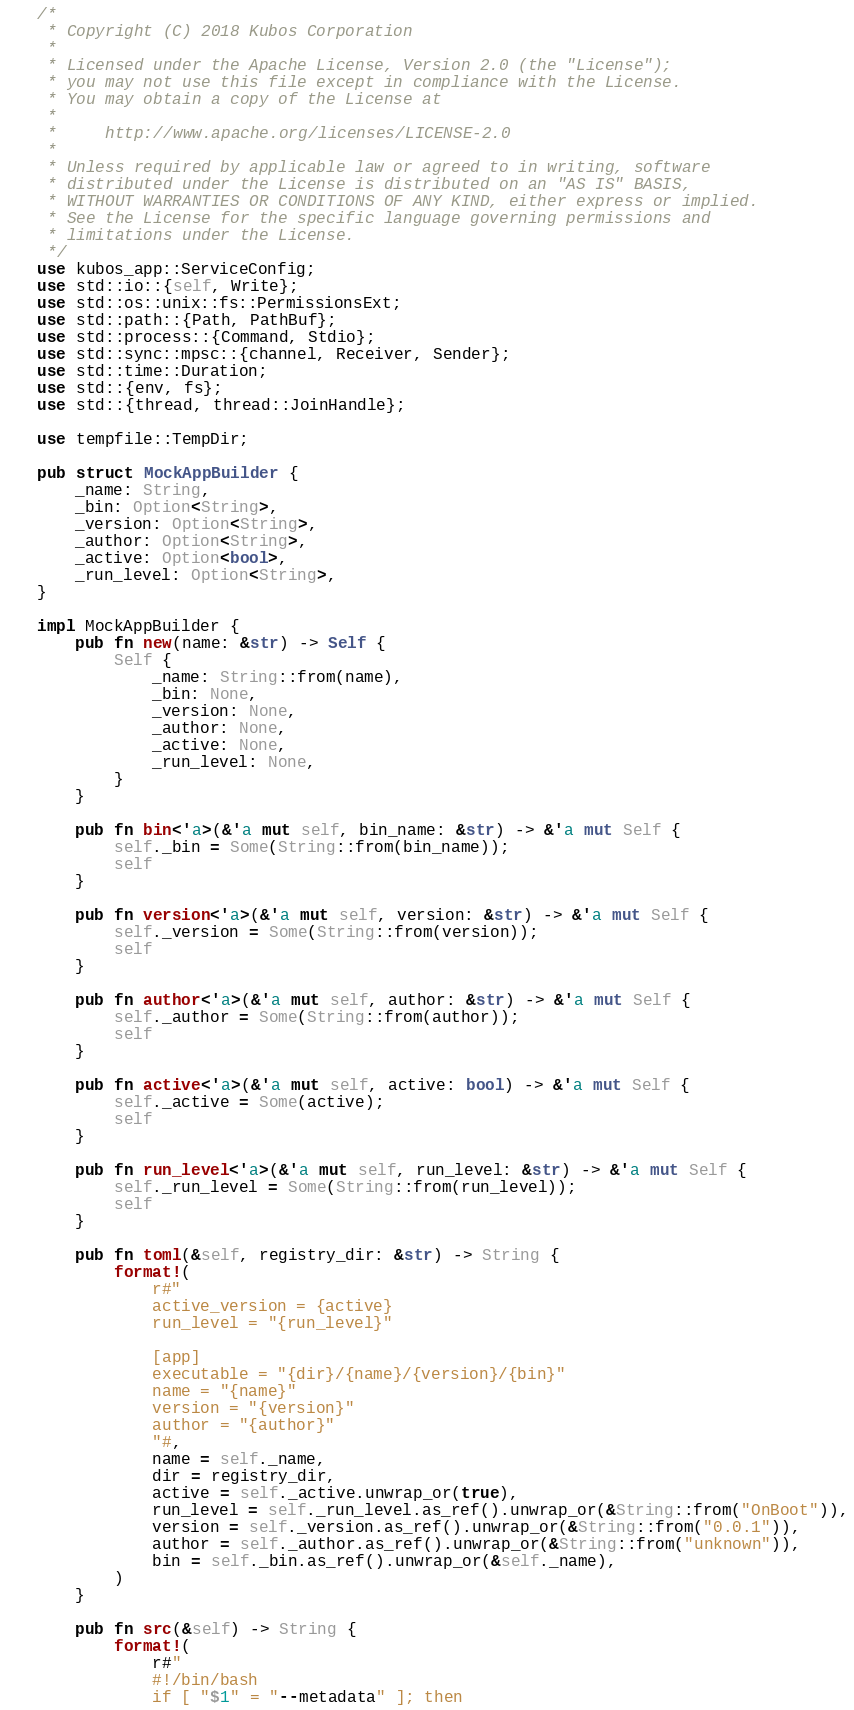<code> <loc_0><loc_0><loc_500><loc_500><_Rust_>/*
 * Copyright (C) 2018 Kubos Corporation
 *
 * Licensed under the Apache License, Version 2.0 (the "License");
 * you may not use this file except in compliance with the License.
 * You may obtain a copy of the License at
 *
 *     http://www.apache.org/licenses/LICENSE-2.0
 *
 * Unless required by applicable law or agreed to in writing, software
 * distributed under the License is distributed on an "AS IS" BASIS,
 * WITHOUT WARRANTIES OR CONDITIONS OF ANY KIND, either express or implied.
 * See the License for the specific language governing permissions and
 * limitations under the License.
 */
use kubos_app::ServiceConfig;
use std::io::{self, Write};
use std::os::unix::fs::PermissionsExt;
use std::path::{Path, PathBuf};
use std::process::{Command, Stdio};
use std::sync::mpsc::{channel, Receiver, Sender};
use std::time::Duration;
use std::{env, fs};
use std::{thread, thread::JoinHandle};

use tempfile::TempDir;

pub struct MockAppBuilder {
    _name: String,
    _bin: Option<String>,
    _version: Option<String>,
    _author: Option<String>,
    _active: Option<bool>,
    _run_level: Option<String>,
}

impl MockAppBuilder {
    pub fn new(name: &str) -> Self {
        Self {
            _name: String::from(name),
            _bin: None,
            _version: None,
            _author: None,
            _active: None,
            _run_level: None,
        }
    }

    pub fn bin<'a>(&'a mut self, bin_name: &str) -> &'a mut Self {
        self._bin = Some(String::from(bin_name));
        self
    }

    pub fn version<'a>(&'a mut self, version: &str) -> &'a mut Self {
        self._version = Some(String::from(version));
        self
    }

    pub fn author<'a>(&'a mut self, author: &str) -> &'a mut Self {
        self._author = Some(String::from(author));
        self
    }

    pub fn active<'a>(&'a mut self, active: bool) -> &'a mut Self {
        self._active = Some(active);
        self
    }

    pub fn run_level<'a>(&'a mut self, run_level: &str) -> &'a mut Self {
        self._run_level = Some(String::from(run_level));
        self
    }

    pub fn toml(&self, registry_dir: &str) -> String {
        format!(
            r#"
            active_version = {active}
            run_level = "{run_level}"

            [app]
            executable = "{dir}/{name}/{version}/{bin}"
            name = "{name}"
            version = "{version}"
            author = "{author}"
            "#,
            name = self._name,
            dir = registry_dir,
            active = self._active.unwrap_or(true),
            run_level = self._run_level.as_ref().unwrap_or(&String::from("OnBoot")),
            version = self._version.as_ref().unwrap_or(&String::from("0.0.1")),
            author = self._author.as_ref().unwrap_or(&String::from("unknown")),
            bin = self._bin.as_ref().unwrap_or(&self._name),
        )
    }

    pub fn src(&self) -> String {
        format!(
            r#"
            #!/bin/bash
            if [ "$1" = "--metadata" ]; then</code> 